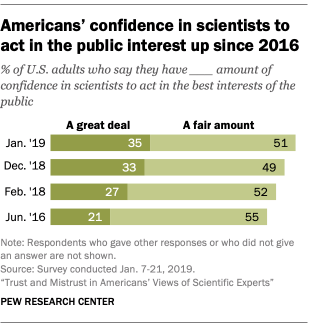Specify some key components in this picture. The years were shown on the y-axis, with a range of 4 years. The task is to find the missing numbers in the sequence of numbers 35, 51, 33, 49, 27, 21, and 55, which spans the range of 52. 